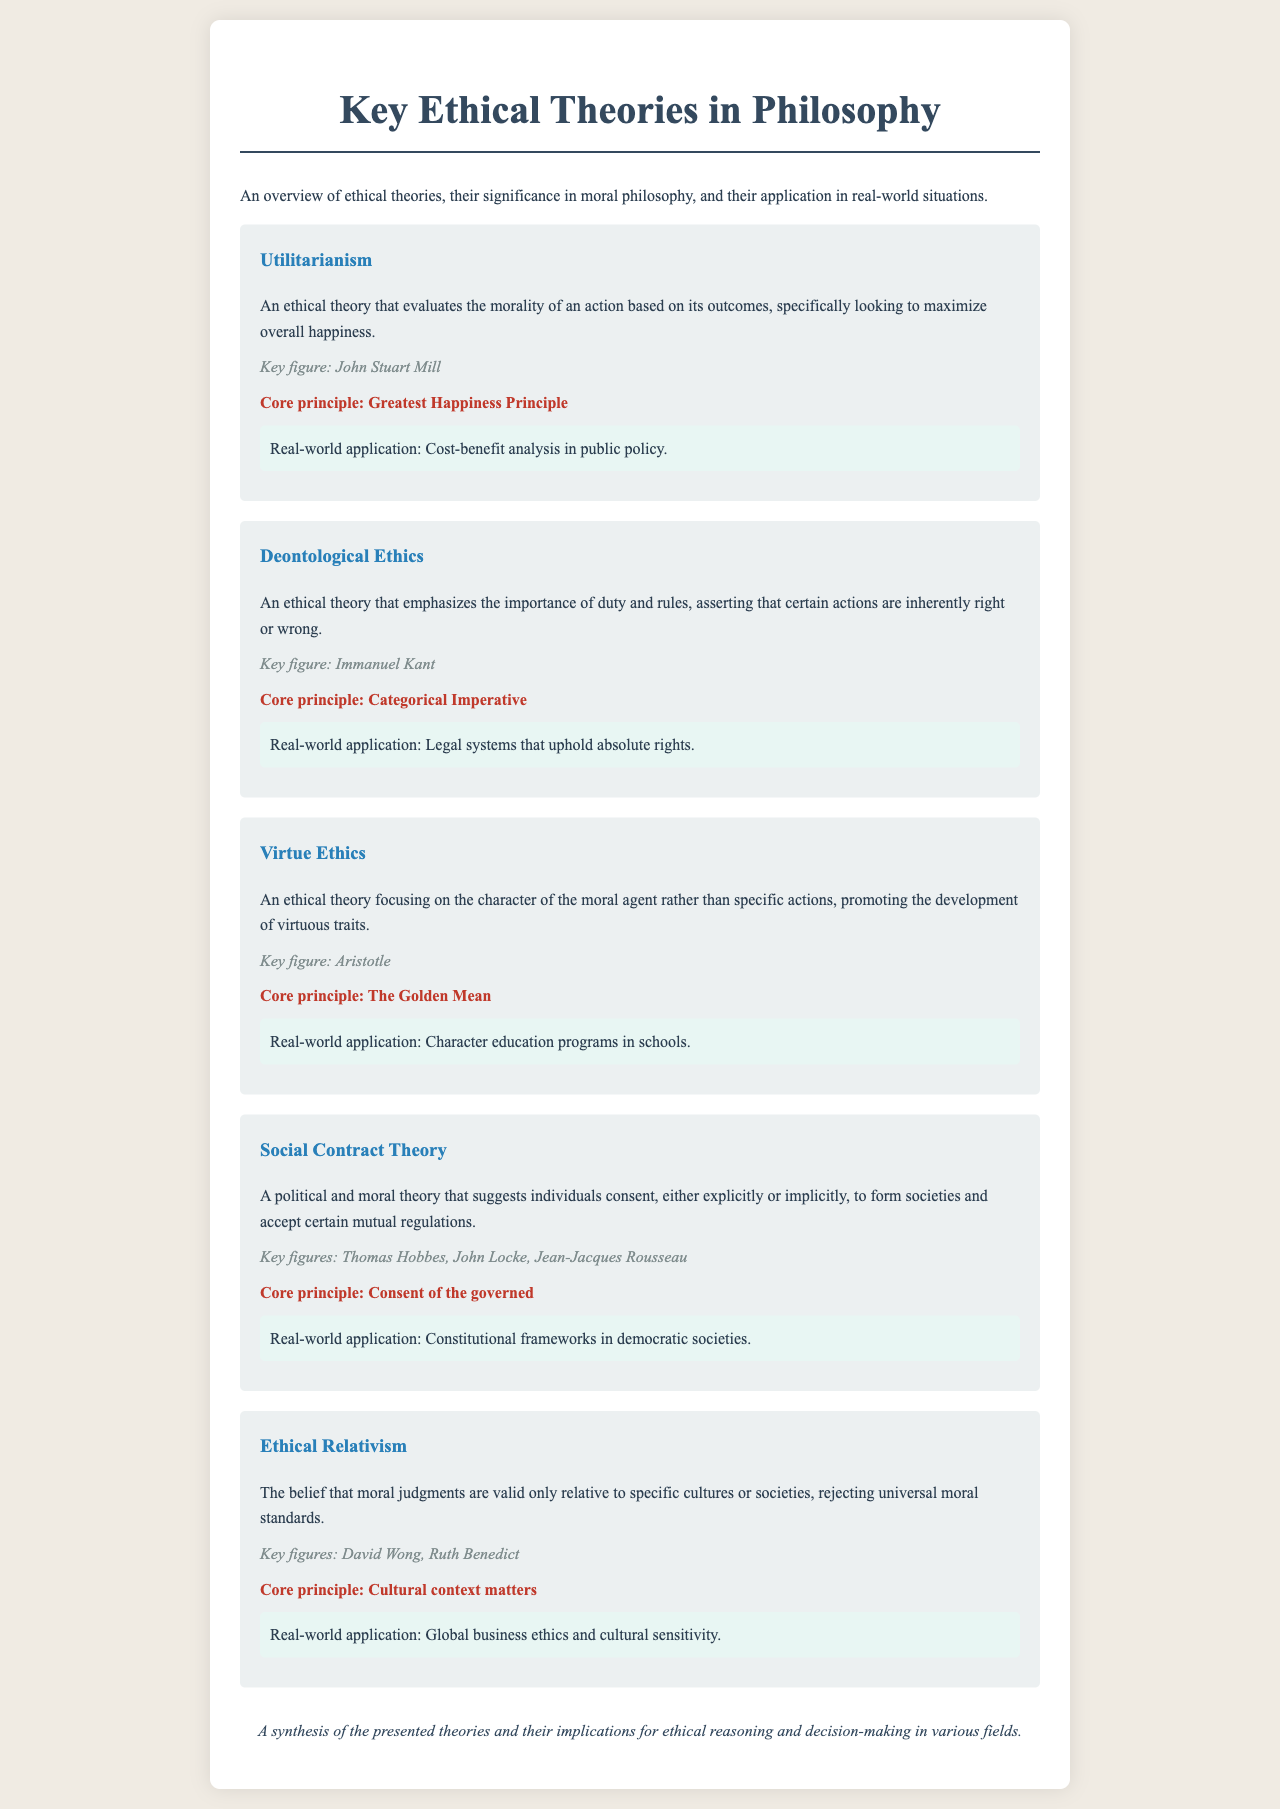What is the main focus of Utilitarianism? Utilitarianism evaluates the morality of an action based on its outcomes, specifically looking to maximize overall happiness.
Answer: maximize overall happiness Who is the key figure associated with Deontological Ethics? The document identifies Immanuel Kant as the key figure for Deontological Ethics.
Answer: Immanuel Kant What core principle is highlighted in Virtue Ethics? The core principle of Virtue Ethics is The Golden Mean.
Answer: The Golden Mean Which ethical theory emphasizes the importance of duty? The ethical theory that emphasizes the importance of duty is Deontological Ethics.
Answer: Deontological Ethics What is the real-world application of Ethical Relativism? Ethical Relativism has a real-world application in global business ethics and cultural sensitivity.
Answer: Global business ethics and cultural sensitivity Who are the key figures in Social Contract Theory? The document lists Thomas Hobbes, John Locke, and Jean-Jacques Rousseau as the key figures in Social Contract Theory.
Answer: Thomas Hobbes, John Locke, Jean-Jacques Rousseau What does the term "consent of the governed" refer to? The term "consent of the governed" refers to a core principle in Social Contract Theory.
Answer: Consent of the governed Why is virtue emphasized in Virtue Ethics? Virtue Ethics focuses on the character of the moral agent rather than specific actions.
Answer: Character of the moral agent What is the conclusion of the presentation slide deck? The conclusion synthesizes the presented theories and their implications for ethical reasoning and decision-making.
Answer: Implications for ethical reasoning and decision-making 